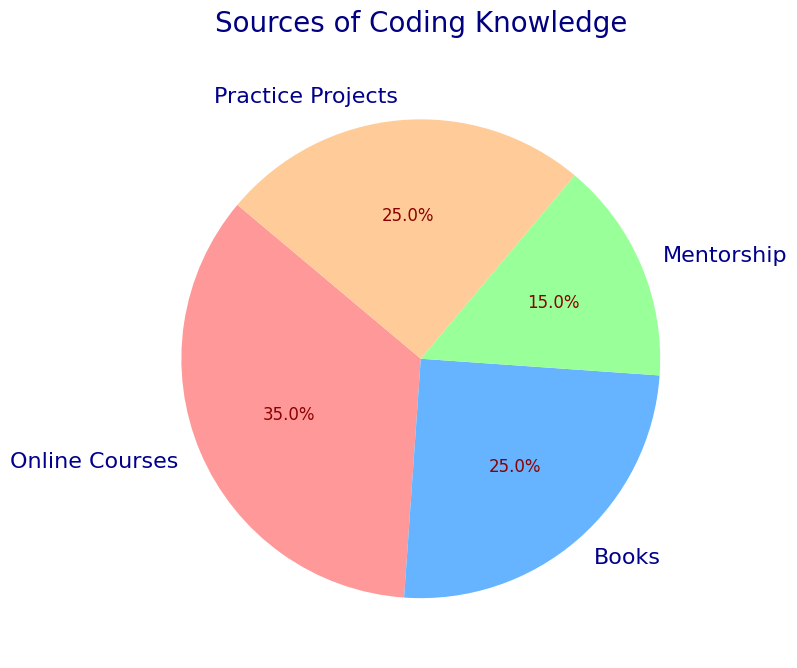What is the most common source of coding knowledge? The largest portion of the pie chart is labeled "Online Courses," indicating it is the most common source.
Answer: Online Courses Which two sources contribute equally to coding knowledge? The pie chart shows that both "Books" and "Practice Projects" each make up 25% of the sources of coding knowledge.
Answer: Books and Practice Projects What is the total percentage of coding knowledge gained from sources other than online courses? Online Courses account for 35% of coding knowledge. By subtracting this from 100%, we get the total percentage for other sources: 100 - 35 = 65%.
Answer: 65% How much more prevalent are online courses compared to mentorship as a source of coding knowledge? Online Courses make up 35% whereas Mentorship makes up 15%. The difference is 35 - 15 = 20%.
Answer: 20% What color represents the practice projects on the pie chart? The practice projects section of the pie chart is depicted in orange color (the description of colors used is not specified, so assumed based on the standard palette).
Answer: Orange If Books and Practice Projects were combined into one category, what would be their combined percentage? Books make up 25% and Practice Projects make up 25%. Combined, they would represent 25 + 25 = 50% of the pie chart.
Answer: 50% Which source of coding knowledge occupies the smallest portion of the pie chart? The smallest portion of the pie chart is labeled "Mentorship," which accounts for 15%.
Answer: Mentorship Rank the sources of coding knowledge from highest to lowest percentage. By viewing the percentages in the pie chart, the sources from highest to lowest are Online Courses (35%), Books and Practice Projects (both 25%), and Mentorship (15%).
Answer: Online Courses > Books = Practice Projects > Mentorship 